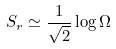<formula> <loc_0><loc_0><loc_500><loc_500>S _ { r } \simeq \frac { 1 } { \sqrt { 2 } } \log \Omega</formula> 